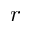Convert formula to latex. <formula><loc_0><loc_0><loc_500><loc_500>r</formula> 